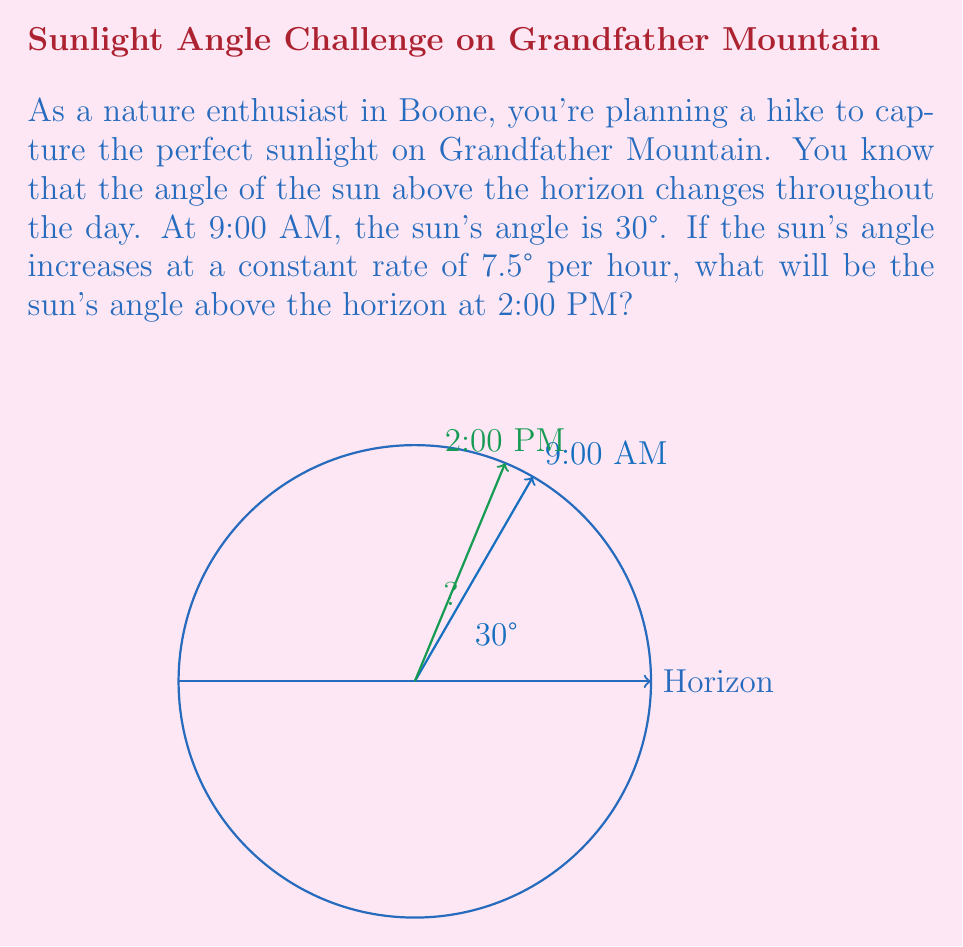Teach me how to tackle this problem. Let's approach this step-by-step:

1) First, we need to calculate the time difference between 9:00 AM and 2:00 PM.
   $2:00\text{ PM} - 9:00\text{ AM} = 5\text{ hours}$

2) We know that the sun's angle increases at a rate of 7.5° per hour.
   So, in 5 hours, the increase will be:
   $5 \times 7.5° = 37.5°$

3) The initial angle at 9:00 AM is given as 30°.
   So, the final angle at 2:00 PM will be:
   $30° + 37.5° = 67.5°$

Therefore, at 2:00 PM, the sun's angle above the horizon will be 67.5°.
Answer: 67.5° 